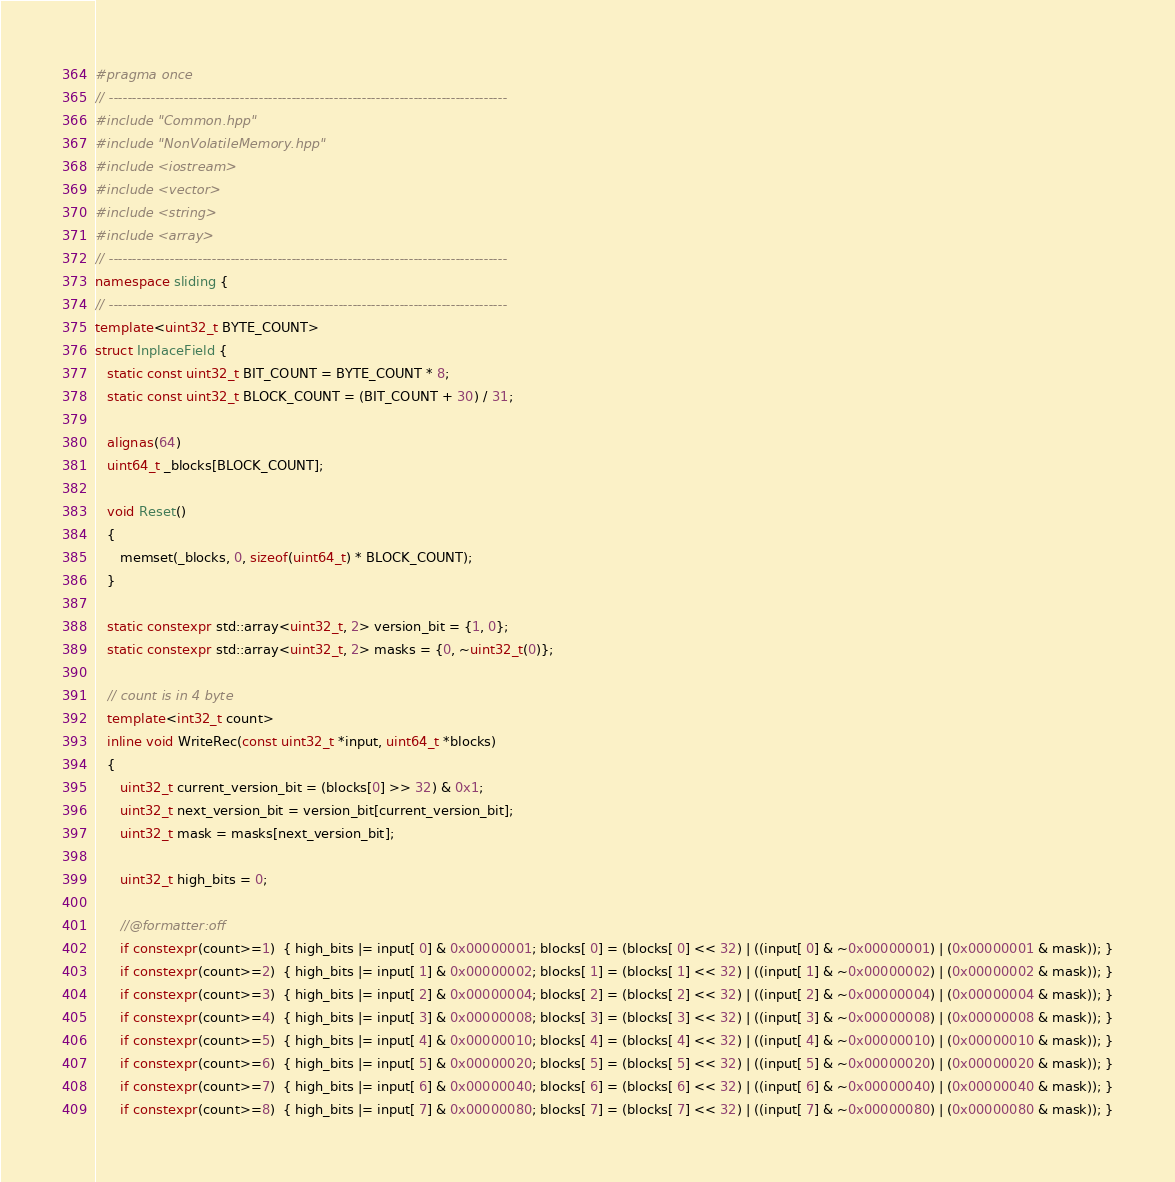Convert code to text. <code><loc_0><loc_0><loc_500><loc_500><_C++_>#pragma once
// -------------------------------------------------------------------------------------
#include "Common.hpp"
#include "NonVolatileMemory.hpp"
#include <iostream>
#include <vector>
#include <string>
#include <array>
// -------------------------------------------------------------------------------------
namespace sliding {
// -------------------------------------------------------------------------------------
template<uint32_t BYTE_COUNT>
struct InplaceField {
   static const uint32_t BIT_COUNT = BYTE_COUNT * 8;
   static const uint32_t BLOCK_COUNT = (BIT_COUNT + 30) / 31;

   alignas(64)
   uint64_t _blocks[BLOCK_COUNT];

   void Reset()
   {
      memset(_blocks, 0, sizeof(uint64_t) * BLOCK_COUNT);
   }

   static constexpr std::array<uint32_t, 2> version_bit = {1, 0};
   static constexpr std::array<uint32_t, 2> masks = {0, ~uint32_t(0)};

   // count is in 4 byte
   template<int32_t count>
   inline void WriteRec(const uint32_t *input, uint64_t *blocks)
   {
      uint32_t current_version_bit = (blocks[0] >> 32) & 0x1;
      uint32_t next_version_bit = version_bit[current_version_bit];
      uint32_t mask = masks[next_version_bit];

      uint32_t high_bits = 0;

      //@formatter:off
      if constexpr(count>=1)  { high_bits |= input[ 0] & 0x00000001; blocks[ 0] = (blocks[ 0] << 32) | ((input[ 0] & ~0x00000001) | (0x00000001 & mask)); }
      if constexpr(count>=2)  { high_bits |= input[ 1] & 0x00000002; blocks[ 1] = (blocks[ 1] << 32) | ((input[ 1] & ~0x00000002) | (0x00000002 & mask)); }
      if constexpr(count>=3)  { high_bits |= input[ 2] & 0x00000004; blocks[ 2] = (blocks[ 2] << 32) | ((input[ 2] & ~0x00000004) | (0x00000004 & mask)); }
      if constexpr(count>=4)  { high_bits |= input[ 3] & 0x00000008; blocks[ 3] = (blocks[ 3] << 32) | ((input[ 3] & ~0x00000008) | (0x00000008 & mask)); }
      if constexpr(count>=5)  { high_bits |= input[ 4] & 0x00000010; blocks[ 4] = (blocks[ 4] << 32) | ((input[ 4] & ~0x00000010) | (0x00000010 & mask)); }
      if constexpr(count>=6)  { high_bits |= input[ 5] & 0x00000020; blocks[ 5] = (blocks[ 5] << 32) | ((input[ 5] & ~0x00000020) | (0x00000020 & mask)); }
      if constexpr(count>=7)  { high_bits |= input[ 6] & 0x00000040; blocks[ 6] = (blocks[ 6] << 32) | ((input[ 6] & ~0x00000040) | (0x00000040 & mask)); }
      if constexpr(count>=8)  { high_bits |= input[ 7] & 0x00000080; blocks[ 7] = (blocks[ 7] << 32) | ((input[ 7] & ~0x00000080) | (0x00000080 & mask)); }</code> 